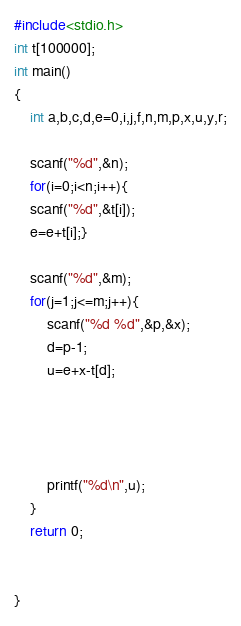Convert code to text. <code><loc_0><loc_0><loc_500><loc_500><_C_>#include<stdio.h>
int t[100000];
int main()
{
    int a,b,c,d,e=0,i,j,f,n,m,p,x,u,y,r;

    scanf("%d",&n);
    for(i=0;i<n;i++){
    scanf("%d",&t[i]);
    e=e+t[i];}

    scanf("%d",&m);
    for(j=1;j<=m;j++){
        scanf("%d %d",&p,&x);
        d=p-1;
        u=e+x-t[d];




        printf("%d\n",u);
    }
    return 0;


}
</code> 